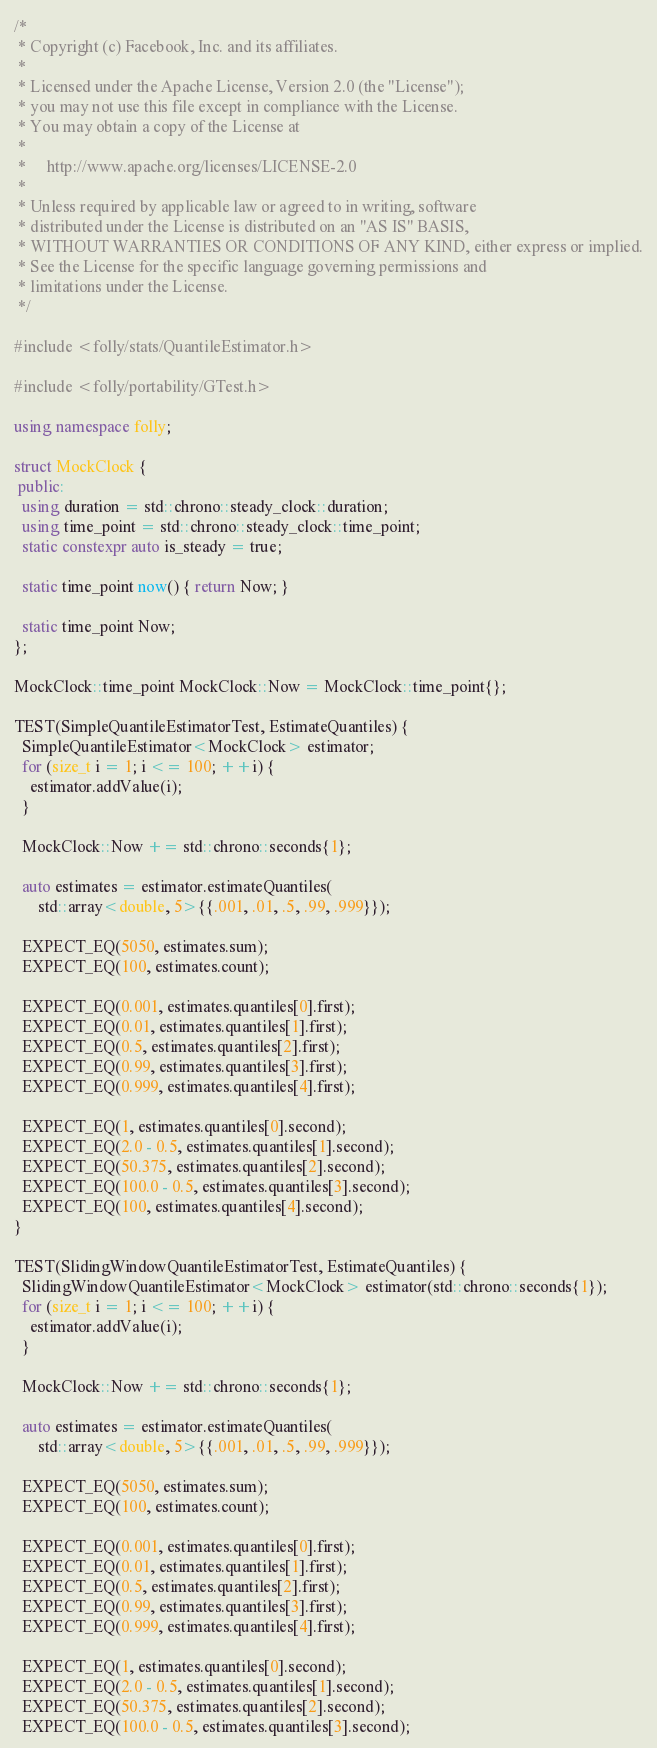Convert code to text. <code><loc_0><loc_0><loc_500><loc_500><_C++_>/*
 * Copyright (c) Facebook, Inc. and its affiliates.
 *
 * Licensed under the Apache License, Version 2.0 (the "License");
 * you may not use this file except in compliance with the License.
 * You may obtain a copy of the License at
 *
 *     http://www.apache.org/licenses/LICENSE-2.0
 *
 * Unless required by applicable law or agreed to in writing, software
 * distributed under the License is distributed on an "AS IS" BASIS,
 * WITHOUT WARRANTIES OR CONDITIONS OF ANY KIND, either express or implied.
 * See the License for the specific language governing permissions and
 * limitations under the License.
 */

#include <folly/stats/QuantileEstimator.h>

#include <folly/portability/GTest.h>

using namespace folly;

struct MockClock {
 public:
  using duration = std::chrono::steady_clock::duration;
  using time_point = std::chrono::steady_clock::time_point;
  static constexpr auto is_steady = true;

  static time_point now() { return Now; }

  static time_point Now;
};

MockClock::time_point MockClock::Now = MockClock::time_point{};

TEST(SimpleQuantileEstimatorTest, EstimateQuantiles) {
  SimpleQuantileEstimator<MockClock> estimator;
  for (size_t i = 1; i <= 100; ++i) {
    estimator.addValue(i);
  }

  MockClock::Now += std::chrono::seconds{1};

  auto estimates = estimator.estimateQuantiles(
      std::array<double, 5>{{.001, .01, .5, .99, .999}});

  EXPECT_EQ(5050, estimates.sum);
  EXPECT_EQ(100, estimates.count);

  EXPECT_EQ(0.001, estimates.quantiles[0].first);
  EXPECT_EQ(0.01, estimates.quantiles[1].first);
  EXPECT_EQ(0.5, estimates.quantiles[2].first);
  EXPECT_EQ(0.99, estimates.quantiles[3].first);
  EXPECT_EQ(0.999, estimates.quantiles[4].first);

  EXPECT_EQ(1, estimates.quantiles[0].second);
  EXPECT_EQ(2.0 - 0.5, estimates.quantiles[1].second);
  EXPECT_EQ(50.375, estimates.quantiles[2].second);
  EXPECT_EQ(100.0 - 0.5, estimates.quantiles[3].second);
  EXPECT_EQ(100, estimates.quantiles[4].second);
}

TEST(SlidingWindowQuantileEstimatorTest, EstimateQuantiles) {
  SlidingWindowQuantileEstimator<MockClock> estimator(std::chrono::seconds{1});
  for (size_t i = 1; i <= 100; ++i) {
    estimator.addValue(i);
  }

  MockClock::Now += std::chrono::seconds{1};

  auto estimates = estimator.estimateQuantiles(
      std::array<double, 5>{{.001, .01, .5, .99, .999}});

  EXPECT_EQ(5050, estimates.sum);
  EXPECT_EQ(100, estimates.count);

  EXPECT_EQ(0.001, estimates.quantiles[0].first);
  EXPECT_EQ(0.01, estimates.quantiles[1].first);
  EXPECT_EQ(0.5, estimates.quantiles[2].first);
  EXPECT_EQ(0.99, estimates.quantiles[3].first);
  EXPECT_EQ(0.999, estimates.quantiles[4].first);

  EXPECT_EQ(1, estimates.quantiles[0].second);
  EXPECT_EQ(2.0 - 0.5, estimates.quantiles[1].second);
  EXPECT_EQ(50.375, estimates.quantiles[2].second);
  EXPECT_EQ(100.0 - 0.5, estimates.quantiles[3].second);</code> 